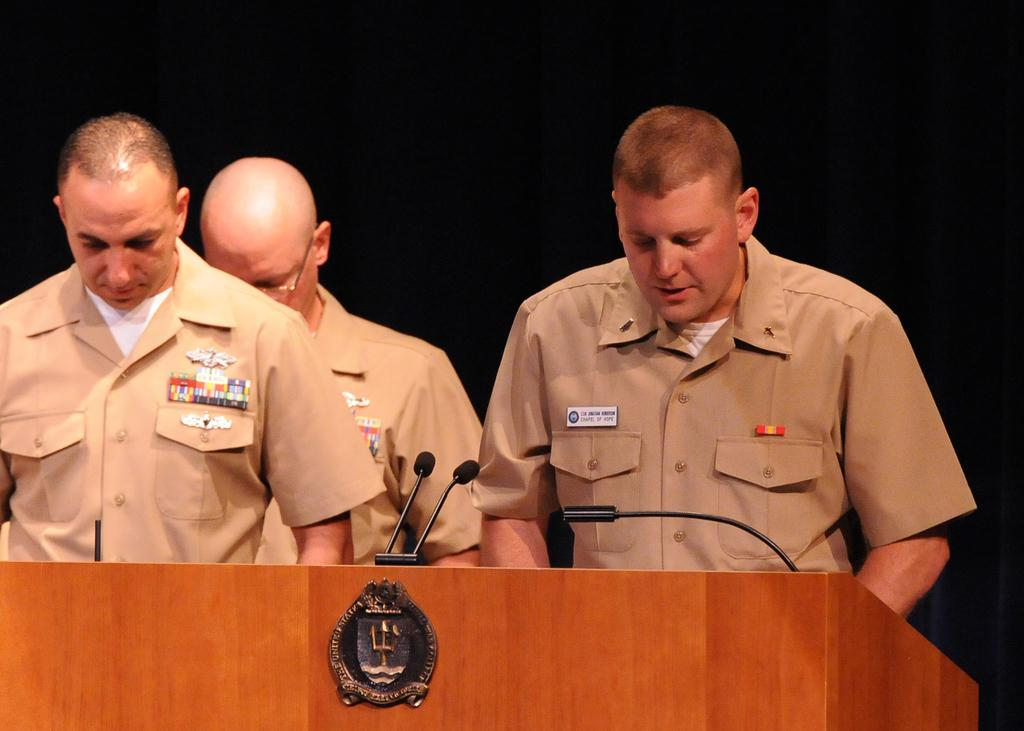What is the main object in the image? There is a podium in the image. What is on the podium? There are miles on the podium. Who is standing near the podium? There are people standing behind the podium. What are the people wearing? The people are wearing uniforms. What color is the background in the image? The background of the image is black. How many pigs are visible behind the curtain in the image? There are no pigs or curtains present in the image. 